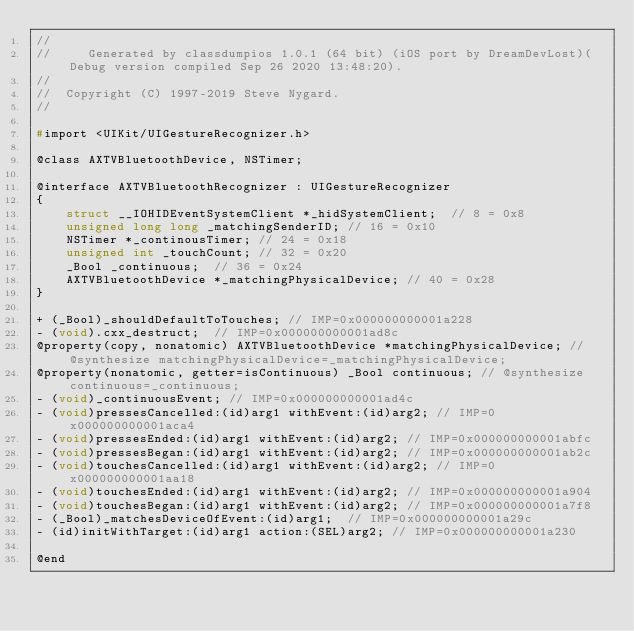<code> <loc_0><loc_0><loc_500><loc_500><_C_>//
//     Generated by classdumpios 1.0.1 (64 bit) (iOS port by DreamDevLost)(Debug version compiled Sep 26 2020 13:48:20).
//
//  Copyright (C) 1997-2019 Steve Nygard.
//

#import <UIKit/UIGestureRecognizer.h>

@class AXTVBluetoothDevice, NSTimer;

@interface AXTVBluetoothRecognizer : UIGestureRecognizer
{
    struct __IOHIDEventSystemClient *_hidSystemClient;	// 8 = 0x8
    unsigned long long _matchingSenderID;	// 16 = 0x10
    NSTimer *_continousTimer;	// 24 = 0x18
    unsigned int _touchCount;	// 32 = 0x20
    _Bool _continuous;	// 36 = 0x24
    AXTVBluetoothDevice *_matchingPhysicalDevice;	// 40 = 0x28
}

+ (_Bool)_shouldDefaultToTouches;	// IMP=0x000000000001a228
- (void).cxx_destruct;	// IMP=0x000000000001ad8c
@property(copy, nonatomic) AXTVBluetoothDevice *matchingPhysicalDevice; // @synthesize matchingPhysicalDevice=_matchingPhysicalDevice;
@property(nonatomic, getter=isContinuous) _Bool continuous; // @synthesize continuous=_continuous;
- (void)_continuousEvent;	// IMP=0x000000000001ad4c
- (void)pressesCancelled:(id)arg1 withEvent:(id)arg2;	// IMP=0x000000000001aca4
- (void)pressesEnded:(id)arg1 withEvent:(id)arg2;	// IMP=0x000000000001abfc
- (void)pressesBegan:(id)arg1 withEvent:(id)arg2;	// IMP=0x000000000001ab2c
- (void)touchesCancelled:(id)arg1 withEvent:(id)arg2;	// IMP=0x000000000001aa18
- (void)touchesEnded:(id)arg1 withEvent:(id)arg2;	// IMP=0x000000000001a904
- (void)touchesBegan:(id)arg1 withEvent:(id)arg2;	// IMP=0x000000000001a7f8
- (_Bool)_matchesDeviceOfEvent:(id)arg1;	// IMP=0x000000000001a29c
- (id)initWithTarget:(id)arg1 action:(SEL)arg2;	// IMP=0x000000000001a230

@end

</code> 